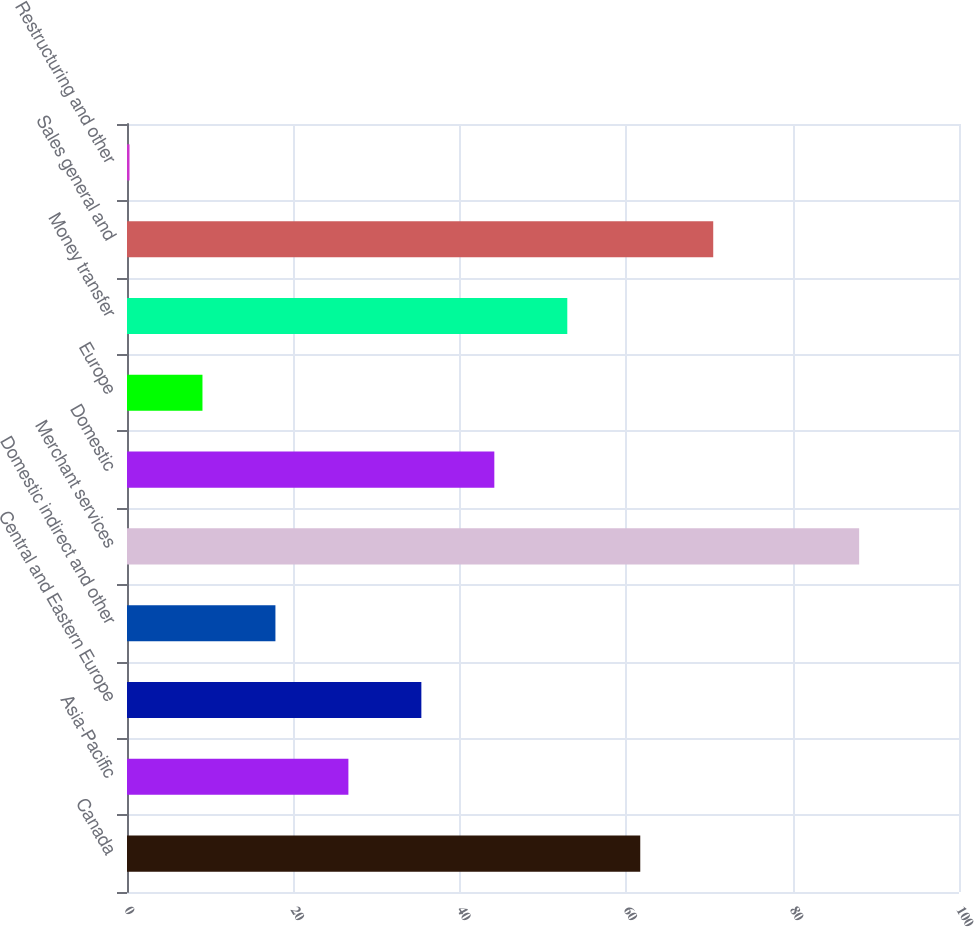Convert chart. <chart><loc_0><loc_0><loc_500><loc_500><bar_chart><fcel>Canada<fcel>Asia-Pacific<fcel>Central and Eastern Europe<fcel>Domestic indirect and other<fcel>Merchant services<fcel>Domestic<fcel>Europe<fcel>Money transfer<fcel>Sales general and<fcel>Restructuring and other<nl><fcel>61.69<fcel>26.61<fcel>35.38<fcel>17.84<fcel>88<fcel>44.15<fcel>9.07<fcel>52.92<fcel>70.46<fcel>0.3<nl></chart> 